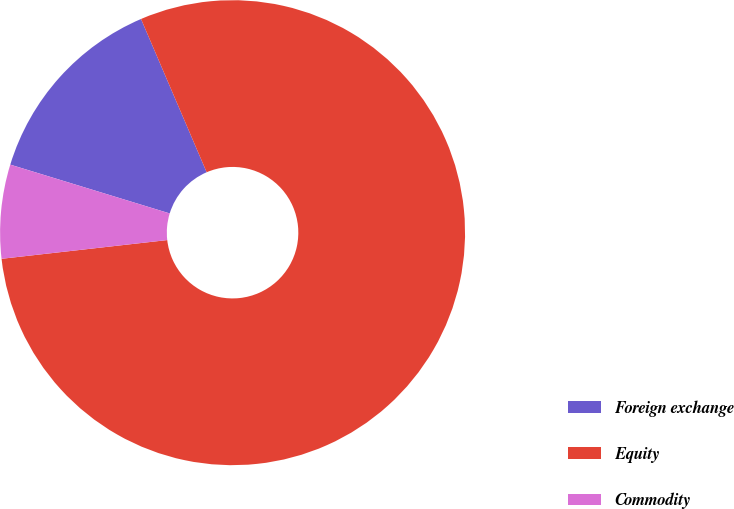Convert chart to OTSL. <chart><loc_0><loc_0><loc_500><loc_500><pie_chart><fcel>Foreign exchange<fcel>Equity<fcel>Commodity<nl><fcel>13.83%<fcel>79.65%<fcel>6.52%<nl></chart> 